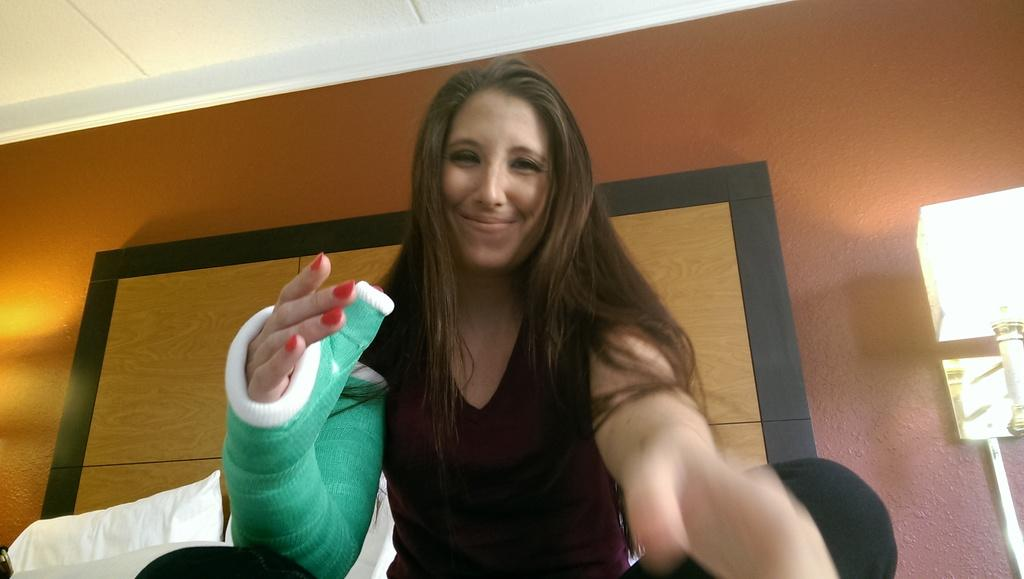What is present in the image? There is a person, a pillow, a wall, and a lamp in the image. Can you describe the person in the image? The provided facts do not give any specific details about the person's appearance or clothing. What is the purpose of the pillow in the image? The purpose of the pillow is not explicitly mentioned in the facts, but it could be for sitting, resting, or decoration. What is the lamp used for in the image? The lamp is likely used for providing light in the room, as it is near the wall in the image. What type of trousers is the person wearing in the image? The provided facts do not give any information about the person's clothing, including trousers. How many quinces are on the wall in the image? There is no mention of quinces in the image; the facts only mention a wall and a lamp near the wall. 